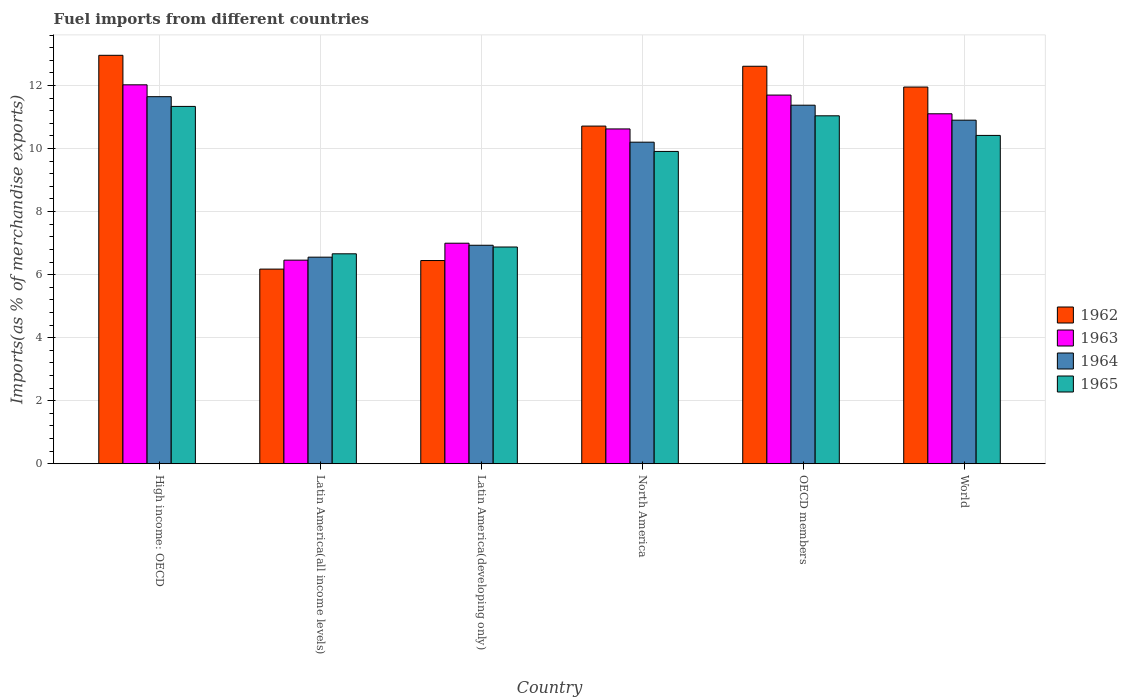Are the number of bars per tick equal to the number of legend labels?
Your response must be concise. Yes. Are the number of bars on each tick of the X-axis equal?
Your answer should be very brief. Yes. How many bars are there on the 5th tick from the left?
Give a very brief answer. 4. What is the label of the 3rd group of bars from the left?
Make the answer very short. Latin America(developing only). What is the percentage of imports to different countries in 1963 in Latin America(developing only)?
Keep it short and to the point. 7. Across all countries, what is the maximum percentage of imports to different countries in 1965?
Ensure brevity in your answer.  11.34. Across all countries, what is the minimum percentage of imports to different countries in 1965?
Ensure brevity in your answer.  6.66. In which country was the percentage of imports to different countries in 1964 maximum?
Offer a very short reply. High income: OECD. In which country was the percentage of imports to different countries in 1962 minimum?
Offer a very short reply. Latin America(all income levels). What is the total percentage of imports to different countries in 1964 in the graph?
Offer a terse response. 57.6. What is the difference between the percentage of imports to different countries in 1963 in North America and that in World?
Provide a succinct answer. -0.48. What is the difference between the percentage of imports to different countries in 1965 in Latin America(developing only) and the percentage of imports to different countries in 1964 in Latin America(all income levels)?
Offer a very short reply. 0.32. What is the average percentage of imports to different countries in 1962 per country?
Your response must be concise. 10.14. What is the difference between the percentage of imports to different countries of/in 1964 and percentage of imports to different countries of/in 1962 in Latin America(developing only)?
Your response must be concise. 0.48. What is the ratio of the percentage of imports to different countries in 1964 in High income: OECD to that in North America?
Your answer should be very brief. 1.14. Is the difference between the percentage of imports to different countries in 1964 in High income: OECD and World greater than the difference between the percentage of imports to different countries in 1962 in High income: OECD and World?
Provide a short and direct response. No. What is the difference between the highest and the second highest percentage of imports to different countries in 1962?
Offer a terse response. -1.01. What is the difference between the highest and the lowest percentage of imports to different countries in 1965?
Your answer should be very brief. 4.68. In how many countries, is the percentage of imports to different countries in 1965 greater than the average percentage of imports to different countries in 1965 taken over all countries?
Your answer should be very brief. 4. Is the sum of the percentage of imports to different countries in 1964 in Latin America(all income levels) and World greater than the maximum percentage of imports to different countries in 1962 across all countries?
Make the answer very short. Yes. What does the 2nd bar from the left in Latin America(all income levels) represents?
Your answer should be compact. 1963. What does the 3rd bar from the right in OECD members represents?
Your response must be concise. 1963. How many bars are there?
Make the answer very short. 24. Are all the bars in the graph horizontal?
Ensure brevity in your answer.  No. Are the values on the major ticks of Y-axis written in scientific E-notation?
Provide a succinct answer. No. Does the graph contain grids?
Your answer should be compact. Yes. Where does the legend appear in the graph?
Provide a short and direct response. Center right. What is the title of the graph?
Keep it short and to the point. Fuel imports from different countries. Does "1993" appear as one of the legend labels in the graph?
Ensure brevity in your answer.  No. What is the label or title of the Y-axis?
Give a very brief answer. Imports(as % of merchandise exports). What is the Imports(as % of merchandise exports) of 1962 in High income: OECD?
Your response must be concise. 12.96. What is the Imports(as % of merchandise exports) of 1963 in High income: OECD?
Your response must be concise. 12.02. What is the Imports(as % of merchandise exports) of 1964 in High income: OECD?
Give a very brief answer. 11.64. What is the Imports(as % of merchandise exports) in 1965 in High income: OECD?
Offer a very short reply. 11.34. What is the Imports(as % of merchandise exports) in 1962 in Latin America(all income levels)?
Provide a short and direct response. 6.17. What is the Imports(as % of merchandise exports) of 1963 in Latin America(all income levels)?
Give a very brief answer. 6.46. What is the Imports(as % of merchandise exports) in 1964 in Latin America(all income levels)?
Your answer should be compact. 6.55. What is the Imports(as % of merchandise exports) in 1965 in Latin America(all income levels)?
Provide a succinct answer. 6.66. What is the Imports(as % of merchandise exports) in 1962 in Latin America(developing only)?
Keep it short and to the point. 6.45. What is the Imports(as % of merchandise exports) in 1963 in Latin America(developing only)?
Your response must be concise. 7. What is the Imports(as % of merchandise exports) of 1964 in Latin America(developing only)?
Make the answer very short. 6.93. What is the Imports(as % of merchandise exports) in 1965 in Latin America(developing only)?
Make the answer very short. 6.88. What is the Imports(as % of merchandise exports) of 1962 in North America?
Your response must be concise. 10.71. What is the Imports(as % of merchandise exports) of 1963 in North America?
Offer a terse response. 10.62. What is the Imports(as % of merchandise exports) of 1964 in North America?
Offer a terse response. 10.2. What is the Imports(as % of merchandise exports) of 1965 in North America?
Make the answer very short. 9.91. What is the Imports(as % of merchandise exports) in 1962 in OECD members?
Ensure brevity in your answer.  12.61. What is the Imports(as % of merchandise exports) of 1963 in OECD members?
Your answer should be very brief. 11.7. What is the Imports(as % of merchandise exports) of 1964 in OECD members?
Offer a very short reply. 11.37. What is the Imports(as % of merchandise exports) in 1965 in OECD members?
Your answer should be compact. 11.04. What is the Imports(as % of merchandise exports) of 1962 in World?
Provide a succinct answer. 11.95. What is the Imports(as % of merchandise exports) of 1963 in World?
Make the answer very short. 11.1. What is the Imports(as % of merchandise exports) in 1964 in World?
Keep it short and to the point. 10.9. What is the Imports(as % of merchandise exports) of 1965 in World?
Provide a short and direct response. 10.42. Across all countries, what is the maximum Imports(as % of merchandise exports) of 1962?
Provide a succinct answer. 12.96. Across all countries, what is the maximum Imports(as % of merchandise exports) in 1963?
Provide a short and direct response. 12.02. Across all countries, what is the maximum Imports(as % of merchandise exports) in 1964?
Offer a terse response. 11.64. Across all countries, what is the maximum Imports(as % of merchandise exports) in 1965?
Keep it short and to the point. 11.34. Across all countries, what is the minimum Imports(as % of merchandise exports) in 1962?
Keep it short and to the point. 6.17. Across all countries, what is the minimum Imports(as % of merchandise exports) in 1963?
Offer a very short reply. 6.46. Across all countries, what is the minimum Imports(as % of merchandise exports) in 1964?
Offer a very short reply. 6.55. Across all countries, what is the minimum Imports(as % of merchandise exports) in 1965?
Give a very brief answer. 6.66. What is the total Imports(as % of merchandise exports) in 1962 in the graph?
Your answer should be compact. 60.85. What is the total Imports(as % of merchandise exports) of 1963 in the graph?
Offer a terse response. 58.9. What is the total Imports(as % of merchandise exports) of 1964 in the graph?
Offer a very short reply. 57.6. What is the total Imports(as % of merchandise exports) of 1965 in the graph?
Provide a short and direct response. 56.23. What is the difference between the Imports(as % of merchandise exports) in 1962 in High income: OECD and that in Latin America(all income levels)?
Provide a short and direct response. 6.78. What is the difference between the Imports(as % of merchandise exports) in 1963 in High income: OECD and that in Latin America(all income levels)?
Your response must be concise. 5.56. What is the difference between the Imports(as % of merchandise exports) in 1964 in High income: OECD and that in Latin America(all income levels)?
Offer a very short reply. 5.09. What is the difference between the Imports(as % of merchandise exports) in 1965 in High income: OECD and that in Latin America(all income levels)?
Your response must be concise. 4.68. What is the difference between the Imports(as % of merchandise exports) in 1962 in High income: OECD and that in Latin America(developing only)?
Offer a very short reply. 6.51. What is the difference between the Imports(as % of merchandise exports) in 1963 in High income: OECD and that in Latin America(developing only)?
Offer a very short reply. 5.02. What is the difference between the Imports(as % of merchandise exports) of 1964 in High income: OECD and that in Latin America(developing only)?
Your response must be concise. 4.71. What is the difference between the Imports(as % of merchandise exports) in 1965 in High income: OECD and that in Latin America(developing only)?
Provide a succinct answer. 4.46. What is the difference between the Imports(as % of merchandise exports) in 1962 in High income: OECD and that in North America?
Keep it short and to the point. 2.25. What is the difference between the Imports(as % of merchandise exports) of 1963 in High income: OECD and that in North America?
Provide a succinct answer. 1.4. What is the difference between the Imports(as % of merchandise exports) of 1964 in High income: OECD and that in North America?
Offer a terse response. 1.44. What is the difference between the Imports(as % of merchandise exports) of 1965 in High income: OECD and that in North America?
Offer a terse response. 1.43. What is the difference between the Imports(as % of merchandise exports) in 1962 in High income: OECD and that in OECD members?
Your answer should be very brief. 0.35. What is the difference between the Imports(as % of merchandise exports) in 1963 in High income: OECD and that in OECD members?
Keep it short and to the point. 0.33. What is the difference between the Imports(as % of merchandise exports) in 1964 in High income: OECD and that in OECD members?
Keep it short and to the point. 0.27. What is the difference between the Imports(as % of merchandise exports) of 1965 in High income: OECD and that in OECD members?
Keep it short and to the point. 0.3. What is the difference between the Imports(as % of merchandise exports) in 1962 in High income: OECD and that in World?
Give a very brief answer. 1.01. What is the difference between the Imports(as % of merchandise exports) in 1963 in High income: OECD and that in World?
Make the answer very short. 0.92. What is the difference between the Imports(as % of merchandise exports) in 1964 in High income: OECD and that in World?
Your answer should be compact. 0.75. What is the difference between the Imports(as % of merchandise exports) in 1965 in High income: OECD and that in World?
Keep it short and to the point. 0.92. What is the difference between the Imports(as % of merchandise exports) in 1962 in Latin America(all income levels) and that in Latin America(developing only)?
Provide a succinct answer. -0.27. What is the difference between the Imports(as % of merchandise exports) in 1963 in Latin America(all income levels) and that in Latin America(developing only)?
Give a very brief answer. -0.54. What is the difference between the Imports(as % of merchandise exports) in 1964 in Latin America(all income levels) and that in Latin America(developing only)?
Keep it short and to the point. -0.38. What is the difference between the Imports(as % of merchandise exports) of 1965 in Latin America(all income levels) and that in Latin America(developing only)?
Provide a short and direct response. -0.22. What is the difference between the Imports(as % of merchandise exports) in 1962 in Latin America(all income levels) and that in North America?
Offer a very short reply. -4.54. What is the difference between the Imports(as % of merchandise exports) of 1963 in Latin America(all income levels) and that in North America?
Your answer should be very brief. -4.16. What is the difference between the Imports(as % of merchandise exports) of 1964 in Latin America(all income levels) and that in North America?
Your answer should be very brief. -3.65. What is the difference between the Imports(as % of merchandise exports) of 1965 in Latin America(all income levels) and that in North America?
Provide a succinct answer. -3.25. What is the difference between the Imports(as % of merchandise exports) of 1962 in Latin America(all income levels) and that in OECD members?
Provide a succinct answer. -6.44. What is the difference between the Imports(as % of merchandise exports) in 1963 in Latin America(all income levels) and that in OECD members?
Give a very brief answer. -5.24. What is the difference between the Imports(as % of merchandise exports) in 1964 in Latin America(all income levels) and that in OECD members?
Provide a short and direct response. -4.82. What is the difference between the Imports(as % of merchandise exports) in 1965 in Latin America(all income levels) and that in OECD members?
Offer a very short reply. -4.38. What is the difference between the Imports(as % of merchandise exports) of 1962 in Latin America(all income levels) and that in World?
Keep it short and to the point. -5.78. What is the difference between the Imports(as % of merchandise exports) of 1963 in Latin America(all income levels) and that in World?
Give a very brief answer. -4.64. What is the difference between the Imports(as % of merchandise exports) in 1964 in Latin America(all income levels) and that in World?
Make the answer very short. -4.35. What is the difference between the Imports(as % of merchandise exports) of 1965 in Latin America(all income levels) and that in World?
Your answer should be compact. -3.76. What is the difference between the Imports(as % of merchandise exports) in 1962 in Latin America(developing only) and that in North America?
Your answer should be very brief. -4.27. What is the difference between the Imports(as % of merchandise exports) in 1963 in Latin America(developing only) and that in North America?
Ensure brevity in your answer.  -3.63. What is the difference between the Imports(as % of merchandise exports) of 1964 in Latin America(developing only) and that in North America?
Offer a terse response. -3.27. What is the difference between the Imports(as % of merchandise exports) of 1965 in Latin America(developing only) and that in North America?
Provide a succinct answer. -3.03. What is the difference between the Imports(as % of merchandise exports) in 1962 in Latin America(developing only) and that in OECD members?
Your response must be concise. -6.16. What is the difference between the Imports(as % of merchandise exports) of 1963 in Latin America(developing only) and that in OECD members?
Provide a short and direct response. -4.7. What is the difference between the Imports(as % of merchandise exports) in 1964 in Latin America(developing only) and that in OECD members?
Your answer should be very brief. -4.44. What is the difference between the Imports(as % of merchandise exports) in 1965 in Latin America(developing only) and that in OECD members?
Provide a succinct answer. -4.16. What is the difference between the Imports(as % of merchandise exports) of 1962 in Latin America(developing only) and that in World?
Keep it short and to the point. -5.5. What is the difference between the Imports(as % of merchandise exports) of 1963 in Latin America(developing only) and that in World?
Your answer should be very brief. -4.11. What is the difference between the Imports(as % of merchandise exports) in 1964 in Latin America(developing only) and that in World?
Ensure brevity in your answer.  -3.97. What is the difference between the Imports(as % of merchandise exports) of 1965 in Latin America(developing only) and that in World?
Your answer should be compact. -3.54. What is the difference between the Imports(as % of merchandise exports) of 1962 in North America and that in OECD members?
Make the answer very short. -1.9. What is the difference between the Imports(as % of merchandise exports) in 1963 in North America and that in OECD members?
Your answer should be compact. -1.07. What is the difference between the Imports(as % of merchandise exports) in 1964 in North America and that in OECD members?
Your answer should be very brief. -1.17. What is the difference between the Imports(as % of merchandise exports) of 1965 in North America and that in OECD members?
Give a very brief answer. -1.13. What is the difference between the Imports(as % of merchandise exports) in 1962 in North America and that in World?
Offer a very short reply. -1.24. What is the difference between the Imports(as % of merchandise exports) of 1963 in North America and that in World?
Give a very brief answer. -0.48. What is the difference between the Imports(as % of merchandise exports) in 1964 in North America and that in World?
Provide a short and direct response. -0.7. What is the difference between the Imports(as % of merchandise exports) of 1965 in North America and that in World?
Offer a very short reply. -0.51. What is the difference between the Imports(as % of merchandise exports) in 1962 in OECD members and that in World?
Provide a short and direct response. 0.66. What is the difference between the Imports(as % of merchandise exports) in 1963 in OECD members and that in World?
Your answer should be very brief. 0.59. What is the difference between the Imports(as % of merchandise exports) of 1964 in OECD members and that in World?
Your answer should be very brief. 0.48. What is the difference between the Imports(as % of merchandise exports) of 1965 in OECD members and that in World?
Your response must be concise. 0.62. What is the difference between the Imports(as % of merchandise exports) in 1962 in High income: OECD and the Imports(as % of merchandise exports) in 1963 in Latin America(all income levels)?
Your answer should be compact. 6.5. What is the difference between the Imports(as % of merchandise exports) of 1962 in High income: OECD and the Imports(as % of merchandise exports) of 1964 in Latin America(all income levels)?
Your answer should be compact. 6.4. What is the difference between the Imports(as % of merchandise exports) in 1962 in High income: OECD and the Imports(as % of merchandise exports) in 1965 in Latin America(all income levels)?
Your answer should be very brief. 6.3. What is the difference between the Imports(as % of merchandise exports) of 1963 in High income: OECD and the Imports(as % of merchandise exports) of 1964 in Latin America(all income levels)?
Keep it short and to the point. 5.47. What is the difference between the Imports(as % of merchandise exports) in 1963 in High income: OECD and the Imports(as % of merchandise exports) in 1965 in Latin America(all income levels)?
Your answer should be compact. 5.36. What is the difference between the Imports(as % of merchandise exports) in 1964 in High income: OECD and the Imports(as % of merchandise exports) in 1965 in Latin America(all income levels)?
Give a very brief answer. 4.98. What is the difference between the Imports(as % of merchandise exports) in 1962 in High income: OECD and the Imports(as % of merchandise exports) in 1963 in Latin America(developing only)?
Your response must be concise. 5.96. What is the difference between the Imports(as % of merchandise exports) in 1962 in High income: OECD and the Imports(as % of merchandise exports) in 1964 in Latin America(developing only)?
Your answer should be very brief. 6.03. What is the difference between the Imports(as % of merchandise exports) in 1962 in High income: OECD and the Imports(as % of merchandise exports) in 1965 in Latin America(developing only)?
Provide a short and direct response. 6.08. What is the difference between the Imports(as % of merchandise exports) of 1963 in High income: OECD and the Imports(as % of merchandise exports) of 1964 in Latin America(developing only)?
Give a very brief answer. 5.09. What is the difference between the Imports(as % of merchandise exports) of 1963 in High income: OECD and the Imports(as % of merchandise exports) of 1965 in Latin America(developing only)?
Make the answer very short. 5.15. What is the difference between the Imports(as % of merchandise exports) of 1964 in High income: OECD and the Imports(as % of merchandise exports) of 1965 in Latin America(developing only)?
Offer a terse response. 4.77. What is the difference between the Imports(as % of merchandise exports) of 1962 in High income: OECD and the Imports(as % of merchandise exports) of 1963 in North America?
Ensure brevity in your answer.  2.34. What is the difference between the Imports(as % of merchandise exports) in 1962 in High income: OECD and the Imports(as % of merchandise exports) in 1964 in North America?
Offer a terse response. 2.76. What is the difference between the Imports(as % of merchandise exports) in 1962 in High income: OECD and the Imports(as % of merchandise exports) in 1965 in North America?
Your response must be concise. 3.05. What is the difference between the Imports(as % of merchandise exports) in 1963 in High income: OECD and the Imports(as % of merchandise exports) in 1964 in North America?
Keep it short and to the point. 1.82. What is the difference between the Imports(as % of merchandise exports) in 1963 in High income: OECD and the Imports(as % of merchandise exports) in 1965 in North America?
Your answer should be very brief. 2.11. What is the difference between the Imports(as % of merchandise exports) in 1964 in High income: OECD and the Imports(as % of merchandise exports) in 1965 in North America?
Your answer should be very brief. 1.74. What is the difference between the Imports(as % of merchandise exports) in 1962 in High income: OECD and the Imports(as % of merchandise exports) in 1963 in OECD members?
Give a very brief answer. 1.26. What is the difference between the Imports(as % of merchandise exports) of 1962 in High income: OECD and the Imports(as % of merchandise exports) of 1964 in OECD members?
Give a very brief answer. 1.58. What is the difference between the Imports(as % of merchandise exports) in 1962 in High income: OECD and the Imports(as % of merchandise exports) in 1965 in OECD members?
Your response must be concise. 1.92. What is the difference between the Imports(as % of merchandise exports) in 1963 in High income: OECD and the Imports(as % of merchandise exports) in 1964 in OECD members?
Provide a succinct answer. 0.65. What is the difference between the Imports(as % of merchandise exports) of 1963 in High income: OECD and the Imports(as % of merchandise exports) of 1965 in OECD members?
Your answer should be compact. 0.98. What is the difference between the Imports(as % of merchandise exports) in 1964 in High income: OECD and the Imports(as % of merchandise exports) in 1965 in OECD members?
Offer a terse response. 0.61. What is the difference between the Imports(as % of merchandise exports) in 1962 in High income: OECD and the Imports(as % of merchandise exports) in 1963 in World?
Your answer should be very brief. 1.86. What is the difference between the Imports(as % of merchandise exports) in 1962 in High income: OECD and the Imports(as % of merchandise exports) in 1964 in World?
Make the answer very short. 2.06. What is the difference between the Imports(as % of merchandise exports) of 1962 in High income: OECD and the Imports(as % of merchandise exports) of 1965 in World?
Ensure brevity in your answer.  2.54. What is the difference between the Imports(as % of merchandise exports) of 1963 in High income: OECD and the Imports(as % of merchandise exports) of 1964 in World?
Make the answer very short. 1.12. What is the difference between the Imports(as % of merchandise exports) of 1963 in High income: OECD and the Imports(as % of merchandise exports) of 1965 in World?
Offer a terse response. 1.61. What is the difference between the Imports(as % of merchandise exports) in 1964 in High income: OECD and the Imports(as % of merchandise exports) in 1965 in World?
Offer a very short reply. 1.23. What is the difference between the Imports(as % of merchandise exports) of 1962 in Latin America(all income levels) and the Imports(as % of merchandise exports) of 1963 in Latin America(developing only)?
Your answer should be compact. -0.82. What is the difference between the Imports(as % of merchandise exports) of 1962 in Latin America(all income levels) and the Imports(as % of merchandise exports) of 1964 in Latin America(developing only)?
Offer a very short reply. -0.76. What is the difference between the Imports(as % of merchandise exports) in 1962 in Latin America(all income levels) and the Imports(as % of merchandise exports) in 1965 in Latin America(developing only)?
Your response must be concise. -0.7. What is the difference between the Imports(as % of merchandise exports) of 1963 in Latin America(all income levels) and the Imports(as % of merchandise exports) of 1964 in Latin America(developing only)?
Provide a succinct answer. -0.47. What is the difference between the Imports(as % of merchandise exports) in 1963 in Latin America(all income levels) and the Imports(as % of merchandise exports) in 1965 in Latin America(developing only)?
Ensure brevity in your answer.  -0.42. What is the difference between the Imports(as % of merchandise exports) in 1964 in Latin America(all income levels) and the Imports(as % of merchandise exports) in 1965 in Latin America(developing only)?
Give a very brief answer. -0.32. What is the difference between the Imports(as % of merchandise exports) of 1962 in Latin America(all income levels) and the Imports(as % of merchandise exports) of 1963 in North America?
Make the answer very short. -4.45. What is the difference between the Imports(as % of merchandise exports) in 1962 in Latin America(all income levels) and the Imports(as % of merchandise exports) in 1964 in North America?
Keep it short and to the point. -4.03. What is the difference between the Imports(as % of merchandise exports) in 1962 in Latin America(all income levels) and the Imports(as % of merchandise exports) in 1965 in North America?
Keep it short and to the point. -3.73. What is the difference between the Imports(as % of merchandise exports) of 1963 in Latin America(all income levels) and the Imports(as % of merchandise exports) of 1964 in North America?
Offer a terse response. -3.74. What is the difference between the Imports(as % of merchandise exports) in 1963 in Latin America(all income levels) and the Imports(as % of merchandise exports) in 1965 in North America?
Provide a short and direct response. -3.45. What is the difference between the Imports(as % of merchandise exports) of 1964 in Latin America(all income levels) and the Imports(as % of merchandise exports) of 1965 in North America?
Offer a very short reply. -3.35. What is the difference between the Imports(as % of merchandise exports) of 1962 in Latin America(all income levels) and the Imports(as % of merchandise exports) of 1963 in OECD members?
Provide a succinct answer. -5.52. What is the difference between the Imports(as % of merchandise exports) in 1962 in Latin America(all income levels) and the Imports(as % of merchandise exports) in 1964 in OECD members?
Give a very brief answer. -5.2. What is the difference between the Imports(as % of merchandise exports) in 1962 in Latin America(all income levels) and the Imports(as % of merchandise exports) in 1965 in OECD members?
Your response must be concise. -4.86. What is the difference between the Imports(as % of merchandise exports) of 1963 in Latin America(all income levels) and the Imports(as % of merchandise exports) of 1964 in OECD members?
Provide a short and direct response. -4.92. What is the difference between the Imports(as % of merchandise exports) in 1963 in Latin America(all income levels) and the Imports(as % of merchandise exports) in 1965 in OECD members?
Provide a short and direct response. -4.58. What is the difference between the Imports(as % of merchandise exports) of 1964 in Latin America(all income levels) and the Imports(as % of merchandise exports) of 1965 in OECD members?
Give a very brief answer. -4.48. What is the difference between the Imports(as % of merchandise exports) in 1962 in Latin America(all income levels) and the Imports(as % of merchandise exports) in 1963 in World?
Keep it short and to the point. -4.93. What is the difference between the Imports(as % of merchandise exports) in 1962 in Latin America(all income levels) and the Imports(as % of merchandise exports) in 1964 in World?
Make the answer very short. -4.72. What is the difference between the Imports(as % of merchandise exports) of 1962 in Latin America(all income levels) and the Imports(as % of merchandise exports) of 1965 in World?
Make the answer very short. -4.24. What is the difference between the Imports(as % of merchandise exports) in 1963 in Latin America(all income levels) and the Imports(as % of merchandise exports) in 1964 in World?
Your response must be concise. -4.44. What is the difference between the Imports(as % of merchandise exports) of 1963 in Latin America(all income levels) and the Imports(as % of merchandise exports) of 1965 in World?
Provide a short and direct response. -3.96. What is the difference between the Imports(as % of merchandise exports) of 1964 in Latin America(all income levels) and the Imports(as % of merchandise exports) of 1965 in World?
Provide a short and direct response. -3.86. What is the difference between the Imports(as % of merchandise exports) in 1962 in Latin America(developing only) and the Imports(as % of merchandise exports) in 1963 in North America?
Keep it short and to the point. -4.17. What is the difference between the Imports(as % of merchandise exports) of 1962 in Latin America(developing only) and the Imports(as % of merchandise exports) of 1964 in North America?
Your response must be concise. -3.75. What is the difference between the Imports(as % of merchandise exports) of 1962 in Latin America(developing only) and the Imports(as % of merchandise exports) of 1965 in North America?
Ensure brevity in your answer.  -3.46. What is the difference between the Imports(as % of merchandise exports) in 1963 in Latin America(developing only) and the Imports(as % of merchandise exports) in 1964 in North America?
Keep it short and to the point. -3.2. What is the difference between the Imports(as % of merchandise exports) in 1963 in Latin America(developing only) and the Imports(as % of merchandise exports) in 1965 in North America?
Offer a terse response. -2.91. What is the difference between the Imports(as % of merchandise exports) in 1964 in Latin America(developing only) and the Imports(as % of merchandise exports) in 1965 in North America?
Offer a terse response. -2.98. What is the difference between the Imports(as % of merchandise exports) in 1962 in Latin America(developing only) and the Imports(as % of merchandise exports) in 1963 in OECD members?
Offer a terse response. -5.25. What is the difference between the Imports(as % of merchandise exports) of 1962 in Latin America(developing only) and the Imports(as % of merchandise exports) of 1964 in OECD members?
Keep it short and to the point. -4.93. What is the difference between the Imports(as % of merchandise exports) in 1962 in Latin America(developing only) and the Imports(as % of merchandise exports) in 1965 in OECD members?
Offer a very short reply. -4.59. What is the difference between the Imports(as % of merchandise exports) in 1963 in Latin America(developing only) and the Imports(as % of merchandise exports) in 1964 in OECD members?
Give a very brief answer. -4.38. What is the difference between the Imports(as % of merchandise exports) in 1963 in Latin America(developing only) and the Imports(as % of merchandise exports) in 1965 in OECD members?
Your answer should be very brief. -4.04. What is the difference between the Imports(as % of merchandise exports) of 1964 in Latin America(developing only) and the Imports(as % of merchandise exports) of 1965 in OECD members?
Offer a terse response. -4.11. What is the difference between the Imports(as % of merchandise exports) of 1962 in Latin America(developing only) and the Imports(as % of merchandise exports) of 1963 in World?
Make the answer very short. -4.66. What is the difference between the Imports(as % of merchandise exports) in 1962 in Latin America(developing only) and the Imports(as % of merchandise exports) in 1964 in World?
Give a very brief answer. -4.45. What is the difference between the Imports(as % of merchandise exports) in 1962 in Latin America(developing only) and the Imports(as % of merchandise exports) in 1965 in World?
Provide a short and direct response. -3.97. What is the difference between the Imports(as % of merchandise exports) of 1963 in Latin America(developing only) and the Imports(as % of merchandise exports) of 1964 in World?
Keep it short and to the point. -3.9. What is the difference between the Imports(as % of merchandise exports) in 1963 in Latin America(developing only) and the Imports(as % of merchandise exports) in 1965 in World?
Give a very brief answer. -3.42. What is the difference between the Imports(as % of merchandise exports) of 1964 in Latin America(developing only) and the Imports(as % of merchandise exports) of 1965 in World?
Your answer should be compact. -3.48. What is the difference between the Imports(as % of merchandise exports) in 1962 in North America and the Imports(as % of merchandise exports) in 1963 in OECD members?
Give a very brief answer. -0.98. What is the difference between the Imports(as % of merchandise exports) of 1962 in North America and the Imports(as % of merchandise exports) of 1964 in OECD members?
Offer a terse response. -0.66. What is the difference between the Imports(as % of merchandise exports) of 1962 in North America and the Imports(as % of merchandise exports) of 1965 in OECD members?
Provide a succinct answer. -0.33. What is the difference between the Imports(as % of merchandise exports) in 1963 in North America and the Imports(as % of merchandise exports) in 1964 in OECD members?
Give a very brief answer. -0.75. What is the difference between the Imports(as % of merchandise exports) in 1963 in North America and the Imports(as % of merchandise exports) in 1965 in OECD members?
Provide a succinct answer. -0.42. What is the difference between the Imports(as % of merchandise exports) of 1964 in North America and the Imports(as % of merchandise exports) of 1965 in OECD members?
Provide a succinct answer. -0.84. What is the difference between the Imports(as % of merchandise exports) of 1962 in North America and the Imports(as % of merchandise exports) of 1963 in World?
Provide a succinct answer. -0.39. What is the difference between the Imports(as % of merchandise exports) of 1962 in North America and the Imports(as % of merchandise exports) of 1964 in World?
Offer a very short reply. -0.19. What is the difference between the Imports(as % of merchandise exports) of 1962 in North America and the Imports(as % of merchandise exports) of 1965 in World?
Your answer should be compact. 0.3. What is the difference between the Imports(as % of merchandise exports) of 1963 in North America and the Imports(as % of merchandise exports) of 1964 in World?
Your response must be concise. -0.28. What is the difference between the Imports(as % of merchandise exports) of 1963 in North America and the Imports(as % of merchandise exports) of 1965 in World?
Your response must be concise. 0.21. What is the difference between the Imports(as % of merchandise exports) in 1964 in North America and the Imports(as % of merchandise exports) in 1965 in World?
Provide a succinct answer. -0.21. What is the difference between the Imports(as % of merchandise exports) of 1962 in OECD members and the Imports(as % of merchandise exports) of 1963 in World?
Your answer should be compact. 1.51. What is the difference between the Imports(as % of merchandise exports) in 1962 in OECD members and the Imports(as % of merchandise exports) in 1964 in World?
Your answer should be compact. 1.71. What is the difference between the Imports(as % of merchandise exports) in 1962 in OECD members and the Imports(as % of merchandise exports) in 1965 in World?
Keep it short and to the point. 2.19. What is the difference between the Imports(as % of merchandise exports) of 1963 in OECD members and the Imports(as % of merchandise exports) of 1964 in World?
Offer a very short reply. 0.8. What is the difference between the Imports(as % of merchandise exports) in 1963 in OECD members and the Imports(as % of merchandise exports) in 1965 in World?
Provide a short and direct response. 1.28. What is the difference between the Imports(as % of merchandise exports) in 1964 in OECD members and the Imports(as % of merchandise exports) in 1965 in World?
Offer a terse response. 0.96. What is the average Imports(as % of merchandise exports) in 1962 per country?
Provide a short and direct response. 10.14. What is the average Imports(as % of merchandise exports) of 1963 per country?
Your answer should be very brief. 9.82. What is the average Imports(as % of merchandise exports) in 1964 per country?
Provide a short and direct response. 9.6. What is the average Imports(as % of merchandise exports) of 1965 per country?
Ensure brevity in your answer.  9.37. What is the difference between the Imports(as % of merchandise exports) of 1962 and Imports(as % of merchandise exports) of 1963 in High income: OECD?
Give a very brief answer. 0.94. What is the difference between the Imports(as % of merchandise exports) in 1962 and Imports(as % of merchandise exports) in 1964 in High income: OECD?
Make the answer very short. 1.31. What is the difference between the Imports(as % of merchandise exports) in 1962 and Imports(as % of merchandise exports) in 1965 in High income: OECD?
Offer a terse response. 1.62. What is the difference between the Imports(as % of merchandise exports) in 1963 and Imports(as % of merchandise exports) in 1964 in High income: OECD?
Give a very brief answer. 0.38. What is the difference between the Imports(as % of merchandise exports) of 1963 and Imports(as % of merchandise exports) of 1965 in High income: OECD?
Your response must be concise. 0.69. What is the difference between the Imports(as % of merchandise exports) of 1964 and Imports(as % of merchandise exports) of 1965 in High income: OECD?
Offer a very short reply. 0.31. What is the difference between the Imports(as % of merchandise exports) of 1962 and Imports(as % of merchandise exports) of 1963 in Latin America(all income levels)?
Keep it short and to the point. -0.28. What is the difference between the Imports(as % of merchandise exports) of 1962 and Imports(as % of merchandise exports) of 1964 in Latin America(all income levels)?
Your response must be concise. -0.38. What is the difference between the Imports(as % of merchandise exports) of 1962 and Imports(as % of merchandise exports) of 1965 in Latin America(all income levels)?
Offer a terse response. -0.48. What is the difference between the Imports(as % of merchandise exports) in 1963 and Imports(as % of merchandise exports) in 1964 in Latin America(all income levels)?
Offer a terse response. -0.09. What is the difference between the Imports(as % of merchandise exports) in 1963 and Imports(as % of merchandise exports) in 1965 in Latin America(all income levels)?
Keep it short and to the point. -0.2. What is the difference between the Imports(as % of merchandise exports) in 1964 and Imports(as % of merchandise exports) in 1965 in Latin America(all income levels)?
Keep it short and to the point. -0.11. What is the difference between the Imports(as % of merchandise exports) in 1962 and Imports(as % of merchandise exports) in 1963 in Latin America(developing only)?
Make the answer very short. -0.55. What is the difference between the Imports(as % of merchandise exports) in 1962 and Imports(as % of merchandise exports) in 1964 in Latin America(developing only)?
Offer a terse response. -0.48. What is the difference between the Imports(as % of merchandise exports) in 1962 and Imports(as % of merchandise exports) in 1965 in Latin America(developing only)?
Provide a short and direct response. -0.43. What is the difference between the Imports(as % of merchandise exports) of 1963 and Imports(as % of merchandise exports) of 1964 in Latin America(developing only)?
Offer a terse response. 0.07. What is the difference between the Imports(as % of merchandise exports) in 1963 and Imports(as % of merchandise exports) in 1965 in Latin America(developing only)?
Give a very brief answer. 0.12. What is the difference between the Imports(as % of merchandise exports) in 1964 and Imports(as % of merchandise exports) in 1965 in Latin America(developing only)?
Ensure brevity in your answer.  0.06. What is the difference between the Imports(as % of merchandise exports) of 1962 and Imports(as % of merchandise exports) of 1963 in North America?
Your answer should be compact. 0.09. What is the difference between the Imports(as % of merchandise exports) of 1962 and Imports(as % of merchandise exports) of 1964 in North America?
Your answer should be compact. 0.51. What is the difference between the Imports(as % of merchandise exports) of 1962 and Imports(as % of merchandise exports) of 1965 in North America?
Your answer should be very brief. 0.8. What is the difference between the Imports(as % of merchandise exports) in 1963 and Imports(as % of merchandise exports) in 1964 in North America?
Provide a short and direct response. 0.42. What is the difference between the Imports(as % of merchandise exports) in 1963 and Imports(as % of merchandise exports) in 1965 in North America?
Your answer should be very brief. 0.71. What is the difference between the Imports(as % of merchandise exports) of 1964 and Imports(as % of merchandise exports) of 1965 in North America?
Make the answer very short. 0.29. What is the difference between the Imports(as % of merchandise exports) in 1962 and Imports(as % of merchandise exports) in 1963 in OECD members?
Keep it short and to the point. 0.91. What is the difference between the Imports(as % of merchandise exports) in 1962 and Imports(as % of merchandise exports) in 1964 in OECD members?
Offer a terse response. 1.24. What is the difference between the Imports(as % of merchandise exports) in 1962 and Imports(as % of merchandise exports) in 1965 in OECD members?
Provide a short and direct response. 1.57. What is the difference between the Imports(as % of merchandise exports) in 1963 and Imports(as % of merchandise exports) in 1964 in OECD members?
Offer a very short reply. 0.32. What is the difference between the Imports(as % of merchandise exports) of 1963 and Imports(as % of merchandise exports) of 1965 in OECD members?
Ensure brevity in your answer.  0.66. What is the difference between the Imports(as % of merchandise exports) in 1964 and Imports(as % of merchandise exports) in 1965 in OECD members?
Ensure brevity in your answer.  0.34. What is the difference between the Imports(as % of merchandise exports) in 1962 and Imports(as % of merchandise exports) in 1963 in World?
Offer a terse response. 0.85. What is the difference between the Imports(as % of merchandise exports) in 1962 and Imports(as % of merchandise exports) in 1964 in World?
Offer a very short reply. 1.05. What is the difference between the Imports(as % of merchandise exports) of 1962 and Imports(as % of merchandise exports) of 1965 in World?
Offer a very short reply. 1.53. What is the difference between the Imports(as % of merchandise exports) of 1963 and Imports(as % of merchandise exports) of 1964 in World?
Your answer should be very brief. 0.2. What is the difference between the Imports(as % of merchandise exports) in 1963 and Imports(as % of merchandise exports) in 1965 in World?
Offer a terse response. 0.69. What is the difference between the Imports(as % of merchandise exports) in 1964 and Imports(as % of merchandise exports) in 1965 in World?
Ensure brevity in your answer.  0.48. What is the ratio of the Imports(as % of merchandise exports) of 1962 in High income: OECD to that in Latin America(all income levels)?
Ensure brevity in your answer.  2.1. What is the ratio of the Imports(as % of merchandise exports) of 1963 in High income: OECD to that in Latin America(all income levels)?
Your answer should be compact. 1.86. What is the ratio of the Imports(as % of merchandise exports) of 1964 in High income: OECD to that in Latin America(all income levels)?
Give a very brief answer. 1.78. What is the ratio of the Imports(as % of merchandise exports) of 1965 in High income: OECD to that in Latin America(all income levels)?
Provide a short and direct response. 1.7. What is the ratio of the Imports(as % of merchandise exports) of 1962 in High income: OECD to that in Latin America(developing only)?
Provide a short and direct response. 2.01. What is the ratio of the Imports(as % of merchandise exports) in 1963 in High income: OECD to that in Latin America(developing only)?
Keep it short and to the point. 1.72. What is the ratio of the Imports(as % of merchandise exports) in 1964 in High income: OECD to that in Latin America(developing only)?
Give a very brief answer. 1.68. What is the ratio of the Imports(as % of merchandise exports) in 1965 in High income: OECD to that in Latin America(developing only)?
Give a very brief answer. 1.65. What is the ratio of the Imports(as % of merchandise exports) in 1962 in High income: OECD to that in North America?
Your answer should be very brief. 1.21. What is the ratio of the Imports(as % of merchandise exports) of 1963 in High income: OECD to that in North America?
Your response must be concise. 1.13. What is the ratio of the Imports(as % of merchandise exports) of 1964 in High income: OECD to that in North America?
Offer a terse response. 1.14. What is the ratio of the Imports(as % of merchandise exports) in 1965 in High income: OECD to that in North America?
Offer a terse response. 1.14. What is the ratio of the Imports(as % of merchandise exports) of 1962 in High income: OECD to that in OECD members?
Provide a succinct answer. 1.03. What is the ratio of the Imports(as % of merchandise exports) of 1963 in High income: OECD to that in OECD members?
Ensure brevity in your answer.  1.03. What is the ratio of the Imports(as % of merchandise exports) in 1964 in High income: OECD to that in OECD members?
Make the answer very short. 1.02. What is the ratio of the Imports(as % of merchandise exports) of 1965 in High income: OECD to that in OECD members?
Offer a terse response. 1.03. What is the ratio of the Imports(as % of merchandise exports) of 1962 in High income: OECD to that in World?
Provide a short and direct response. 1.08. What is the ratio of the Imports(as % of merchandise exports) of 1963 in High income: OECD to that in World?
Make the answer very short. 1.08. What is the ratio of the Imports(as % of merchandise exports) of 1964 in High income: OECD to that in World?
Your response must be concise. 1.07. What is the ratio of the Imports(as % of merchandise exports) in 1965 in High income: OECD to that in World?
Offer a very short reply. 1.09. What is the ratio of the Imports(as % of merchandise exports) of 1962 in Latin America(all income levels) to that in Latin America(developing only)?
Provide a short and direct response. 0.96. What is the ratio of the Imports(as % of merchandise exports) in 1963 in Latin America(all income levels) to that in Latin America(developing only)?
Give a very brief answer. 0.92. What is the ratio of the Imports(as % of merchandise exports) of 1964 in Latin America(all income levels) to that in Latin America(developing only)?
Your answer should be compact. 0.95. What is the ratio of the Imports(as % of merchandise exports) of 1965 in Latin America(all income levels) to that in Latin America(developing only)?
Keep it short and to the point. 0.97. What is the ratio of the Imports(as % of merchandise exports) of 1962 in Latin America(all income levels) to that in North America?
Keep it short and to the point. 0.58. What is the ratio of the Imports(as % of merchandise exports) in 1963 in Latin America(all income levels) to that in North America?
Provide a short and direct response. 0.61. What is the ratio of the Imports(as % of merchandise exports) of 1964 in Latin America(all income levels) to that in North America?
Your response must be concise. 0.64. What is the ratio of the Imports(as % of merchandise exports) of 1965 in Latin America(all income levels) to that in North America?
Keep it short and to the point. 0.67. What is the ratio of the Imports(as % of merchandise exports) of 1962 in Latin America(all income levels) to that in OECD members?
Provide a short and direct response. 0.49. What is the ratio of the Imports(as % of merchandise exports) in 1963 in Latin America(all income levels) to that in OECD members?
Provide a succinct answer. 0.55. What is the ratio of the Imports(as % of merchandise exports) in 1964 in Latin America(all income levels) to that in OECD members?
Provide a succinct answer. 0.58. What is the ratio of the Imports(as % of merchandise exports) in 1965 in Latin America(all income levels) to that in OECD members?
Your response must be concise. 0.6. What is the ratio of the Imports(as % of merchandise exports) of 1962 in Latin America(all income levels) to that in World?
Provide a short and direct response. 0.52. What is the ratio of the Imports(as % of merchandise exports) of 1963 in Latin America(all income levels) to that in World?
Provide a succinct answer. 0.58. What is the ratio of the Imports(as % of merchandise exports) of 1964 in Latin America(all income levels) to that in World?
Offer a very short reply. 0.6. What is the ratio of the Imports(as % of merchandise exports) of 1965 in Latin America(all income levels) to that in World?
Keep it short and to the point. 0.64. What is the ratio of the Imports(as % of merchandise exports) in 1962 in Latin America(developing only) to that in North America?
Your answer should be very brief. 0.6. What is the ratio of the Imports(as % of merchandise exports) of 1963 in Latin America(developing only) to that in North America?
Offer a terse response. 0.66. What is the ratio of the Imports(as % of merchandise exports) of 1964 in Latin America(developing only) to that in North America?
Your answer should be very brief. 0.68. What is the ratio of the Imports(as % of merchandise exports) in 1965 in Latin America(developing only) to that in North America?
Your answer should be compact. 0.69. What is the ratio of the Imports(as % of merchandise exports) of 1962 in Latin America(developing only) to that in OECD members?
Give a very brief answer. 0.51. What is the ratio of the Imports(as % of merchandise exports) of 1963 in Latin America(developing only) to that in OECD members?
Your response must be concise. 0.6. What is the ratio of the Imports(as % of merchandise exports) of 1964 in Latin America(developing only) to that in OECD members?
Offer a very short reply. 0.61. What is the ratio of the Imports(as % of merchandise exports) of 1965 in Latin America(developing only) to that in OECD members?
Make the answer very short. 0.62. What is the ratio of the Imports(as % of merchandise exports) of 1962 in Latin America(developing only) to that in World?
Your answer should be compact. 0.54. What is the ratio of the Imports(as % of merchandise exports) of 1963 in Latin America(developing only) to that in World?
Make the answer very short. 0.63. What is the ratio of the Imports(as % of merchandise exports) in 1964 in Latin America(developing only) to that in World?
Provide a succinct answer. 0.64. What is the ratio of the Imports(as % of merchandise exports) in 1965 in Latin America(developing only) to that in World?
Offer a terse response. 0.66. What is the ratio of the Imports(as % of merchandise exports) in 1962 in North America to that in OECD members?
Provide a short and direct response. 0.85. What is the ratio of the Imports(as % of merchandise exports) in 1963 in North America to that in OECD members?
Make the answer very short. 0.91. What is the ratio of the Imports(as % of merchandise exports) in 1964 in North America to that in OECD members?
Your response must be concise. 0.9. What is the ratio of the Imports(as % of merchandise exports) in 1965 in North America to that in OECD members?
Make the answer very short. 0.9. What is the ratio of the Imports(as % of merchandise exports) of 1962 in North America to that in World?
Your answer should be very brief. 0.9. What is the ratio of the Imports(as % of merchandise exports) in 1963 in North America to that in World?
Your answer should be very brief. 0.96. What is the ratio of the Imports(as % of merchandise exports) in 1964 in North America to that in World?
Your answer should be very brief. 0.94. What is the ratio of the Imports(as % of merchandise exports) in 1965 in North America to that in World?
Keep it short and to the point. 0.95. What is the ratio of the Imports(as % of merchandise exports) of 1962 in OECD members to that in World?
Keep it short and to the point. 1.06. What is the ratio of the Imports(as % of merchandise exports) of 1963 in OECD members to that in World?
Your response must be concise. 1.05. What is the ratio of the Imports(as % of merchandise exports) in 1964 in OECD members to that in World?
Keep it short and to the point. 1.04. What is the ratio of the Imports(as % of merchandise exports) in 1965 in OECD members to that in World?
Your answer should be very brief. 1.06. What is the difference between the highest and the second highest Imports(as % of merchandise exports) of 1962?
Offer a terse response. 0.35. What is the difference between the highest and the second highest Imports(as % of merchandise exports) in 1963?
Offer a very short reply. 0.33. What is the difference between the highest and the second highest Imports(as % of merchandise exports) of 1964?
Provide a short and direct response. 0.27. What is the difference between the highest and the second highest Imports(as % of merchandise exports) in 1965?
Offer a terse response. 0.3. What is the difference between the highest and the lowest Imports(as % of merchandise exports) in 1962?
Your answer should be very brief. 6.78. What is the difference between the highest and the lowest Imports(as % of merchandise exports) in 1963?
Give a very brief answer. 5.56. What is the difference between the highest and the lowest Imports(as % of merchandise exports) in 1964?
Make the answer very short. 5.09. What is the difference between the highest and the lowest Imports(as % of merchandise exports) of 1965?
Keep it short and to the point. 4.68. 